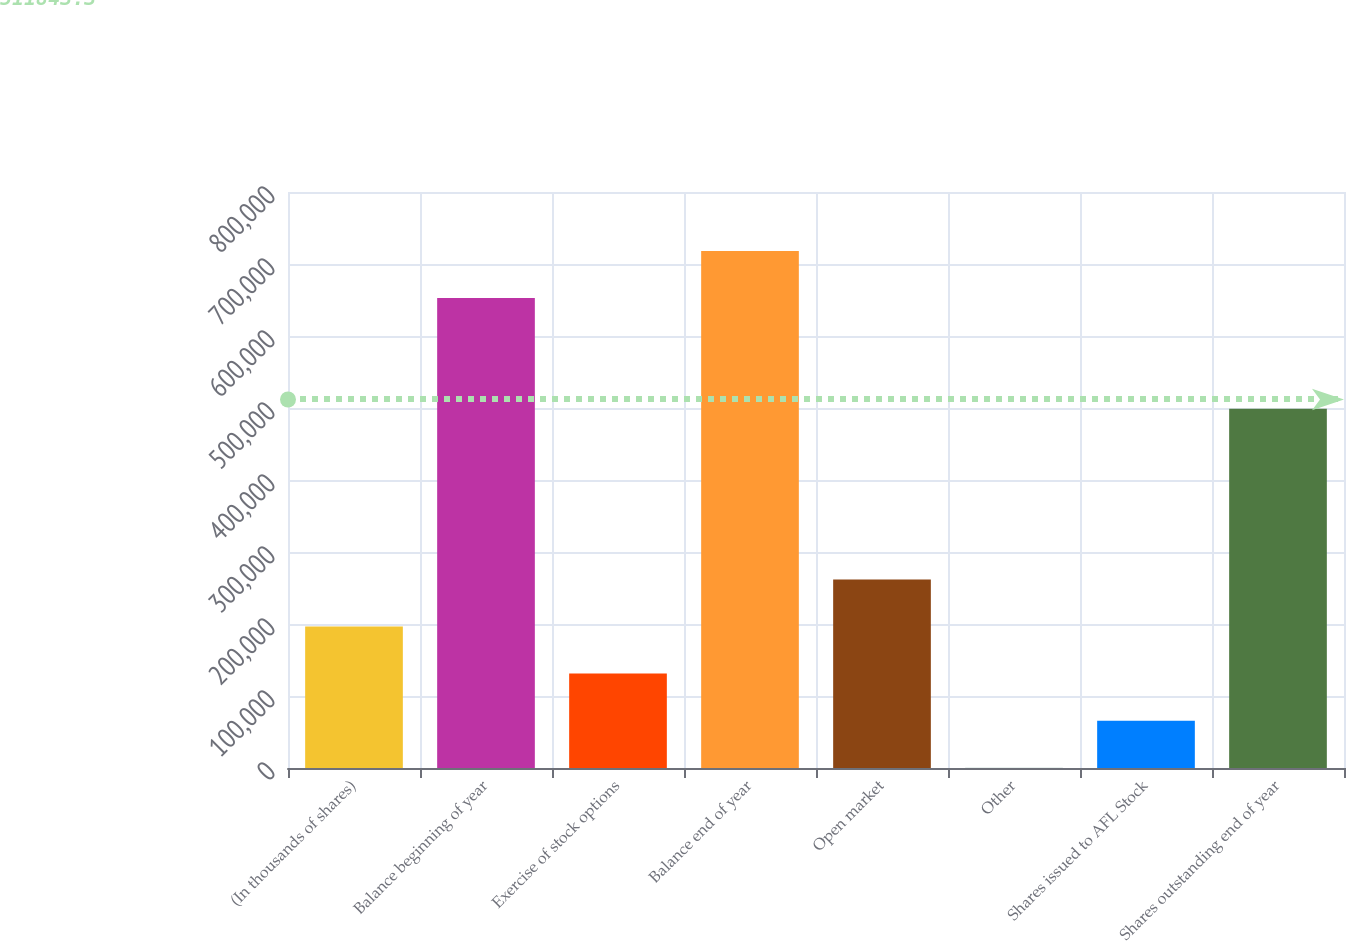Convert chart to OTSL. <chart><loc_0><loc_0><loc_500><loc_500><bar_chart><fcel>(In thousands of shares)<fcel>Balance beginning of year<fcel>Exercise of stock options<fcel>Balance end of year<fcel>Open market<fcel>Other<fcel>Shares issued to AFL Stock<fcel>Shares outstanding end of year<nl><fcel>196528<fcel>652628<fcel>131100<fcel>718056<fcel>261956<fcel>245<fcel>65672.7<fcel>498894<nl></chart> 